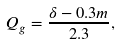Convert formula to latex. <formula><loc_0><loc_0><loc_500><loc_500>Q _ { g } = \frac { \delta - 0 . 3 m } { 2 . 3 } ,</formula> 